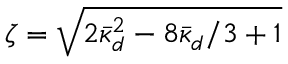<formula> <loc_0><loc_0><loc_500><loc_500>\zeta = \sqrt { 2 \bar { \kappa } _ { d } ^ { 2 } - 8 \bar { \kappa } _ { d } / 3 + 1 }</formula> 